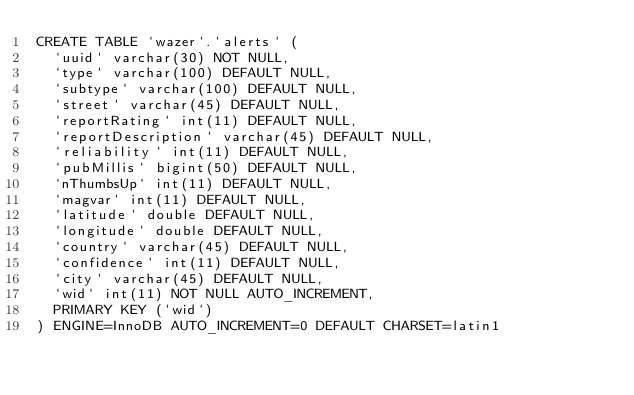<code> <loc_0><loc_0><loc_500><loc_500><_SQL_>CREATE TABLE `wazer`.`alerts` (
  `uuid` varchar(30) NOT NULL,
  `type` varchar(100) DEFAULT NULL,
  `subtype` varchar(100) DEFAULT NULL,
  `street` varchar(45) DEFAULT NULL,
  `reportRating` int(11) DEFAULT NULL,
  `reportDescription` varchar(45) DEFAULT NULL,
  `reliability` int(11) DEFAULT NULL,
  `pubMillis` bigint(50) DEFAULT NULL,
  `nThumbsUp` int(11) DEFAULT NULL,
  `magvar` int(11) DEFAULT NULL,
  `latitude` double DEFAULT NULL,
  `longitude` double DEFAULT NULL,
  `country` varchar(45) DEFAULT NULL,
  `confidence` int(11) DEFAULT NULL,
  `city` varchar(45) DEFAULT NULL,
  `wid` int(11) NOT NULL AUTO_INCREMENT,
  PRIMARY KEY (`wid`)
) ENGINE=InnoDB AUTO_INCREMENT=0 DEFAULT CHARSET=latin1</code> 